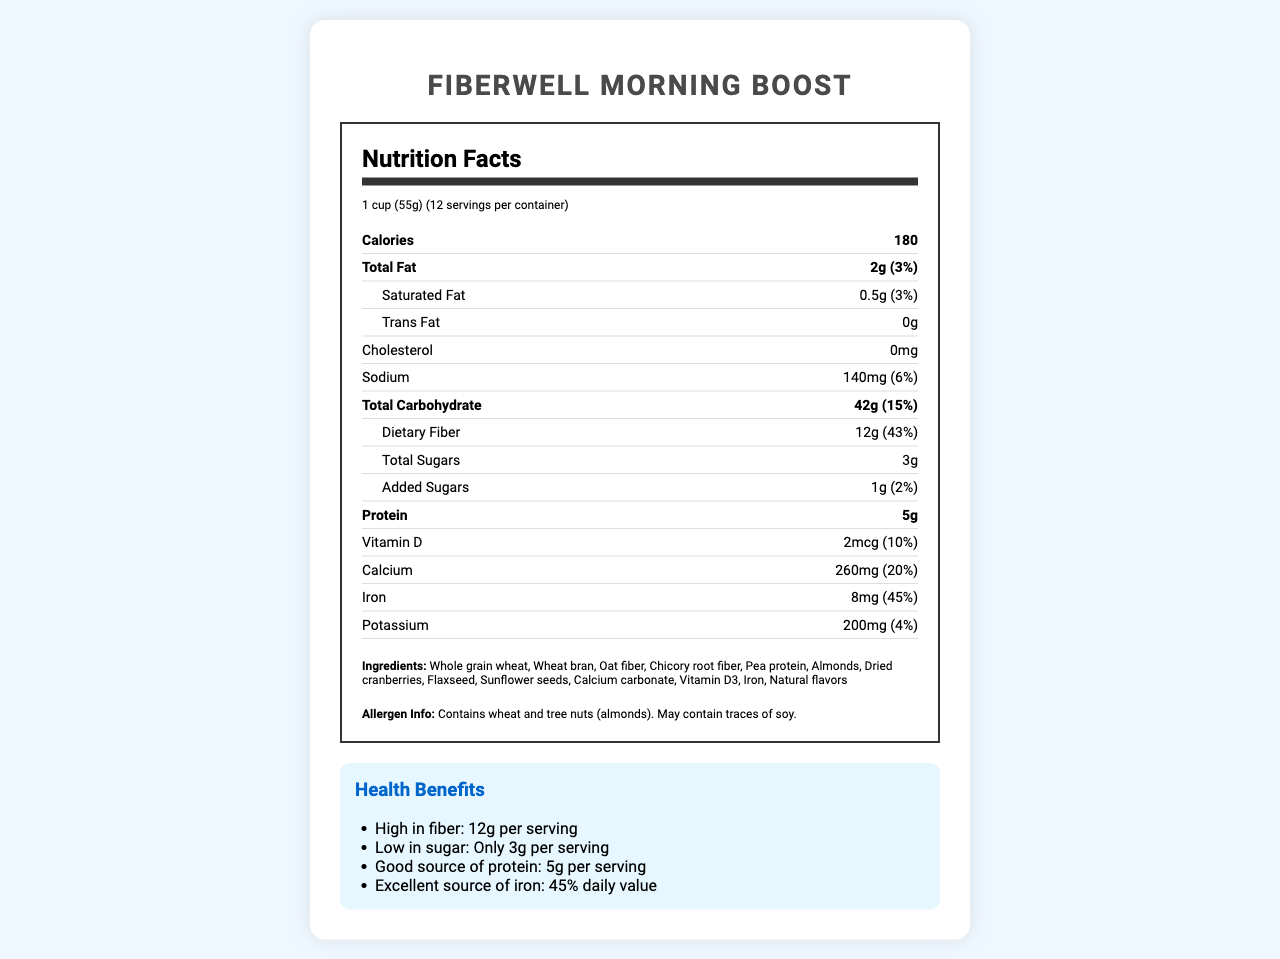What is the serving size of FiberWell Morning Boost? The serving size is mentioned at the top of the Nutrition Facts section.
Answer: 1 cup (55g) How many calories are there per serving? The calories per serving are listed under the Nutrition Facts section right after the serving size information.
Answer: 180 What is the total amount of dietary fiber per serving? The amount of dietary fiber is stated under the Total Carbohydrate section in the Nutrition Facts.
Answer: 12g How many grams of protein does each serving provide? The protein content is listed towards the bottom of the Nutrition Facts section.
Answer: 5g What is the allergen information for this product? The allergen information is provided at the end of the ingredients list.
Answer: Contains wheat and tree nuts (almonds). May contain traces of soy. What are the main ingredients in FiberWell Morning Boost? A. Oats, Almonds, Rice B. Whole grain wheat, Wheat bran, Oat fiber C. Corn, Beans, Sugars D. Milk, Peanuts, Honey The ingredients list states Whole grain wheat, Wheat bran, Oat fiber as the first few ingredients.
Answer: B Which of the following is true about the sugar content of this cereal? A. It has no added sugars B. It contains 10g of total sugars C. It has 1g of added sugars D. It does not contain any sugar The total sugars and added sugars are listed in the Nutrition Facts section, mentioning that it contains 3g total sugars and 1g added sugars.
Answer: C Does this cereal promote digestive health? One of the product benefits specifically states that it promotes digestive health.
Answer: Yes How many servings are there per container? The number of servings per container is listed at the top of the Nutrition Facts section.
Answer: 12 Summarize the main benefits of consuming FiberWell Morning Boost. This summary includes various health benefits provided by the cereal as stated under the Health Benefits section.
Answer: FiberWell Morning Boost is a high-fiber, low-sugar breakfast cereal that promotes digestive health, supports regular bowel movements, helps maintain steady blood sugar levels, provides sustained energy throughout the morning, and supports weight management goals. What is the manufacturer’s customer service hotline number? The customer service hotline number is provided at the end of the document in the extra information section.
Answer: 1-800-FIBER-WELL Can you determine if it's safe for people with peanut allergies to consume this cereal? The document provides allergen information about wheat, tree nuts (almonds), and traces of soy but does not mention peanuts specifically.
Answer: Not enough information How much calcium is provided per serving and what is its daily value percentage? The amount of calcium and its daily value percentage are listed together in the Nutrition Facts section.
Answer: 260mg, 20% What is the social media handle for FiberWell Morning Boost on Instagram? The Instagram handle is listed in the extra information section under social media handles.
Answer: @fiber_well_boost Which vitamin listed is found in FiberWell Morning Boost? A. Vitamin A B. Vitamin B12 C. Vitamin C D. Vitamin D The Nutrition Facts specifically mention Vitamin D content.
Answer: D How many grams of saturated fat does each serving contain? The amount of saturated fat is provided within the Total Fat section in the Nutrition Facts.
Answer: 0.5g 